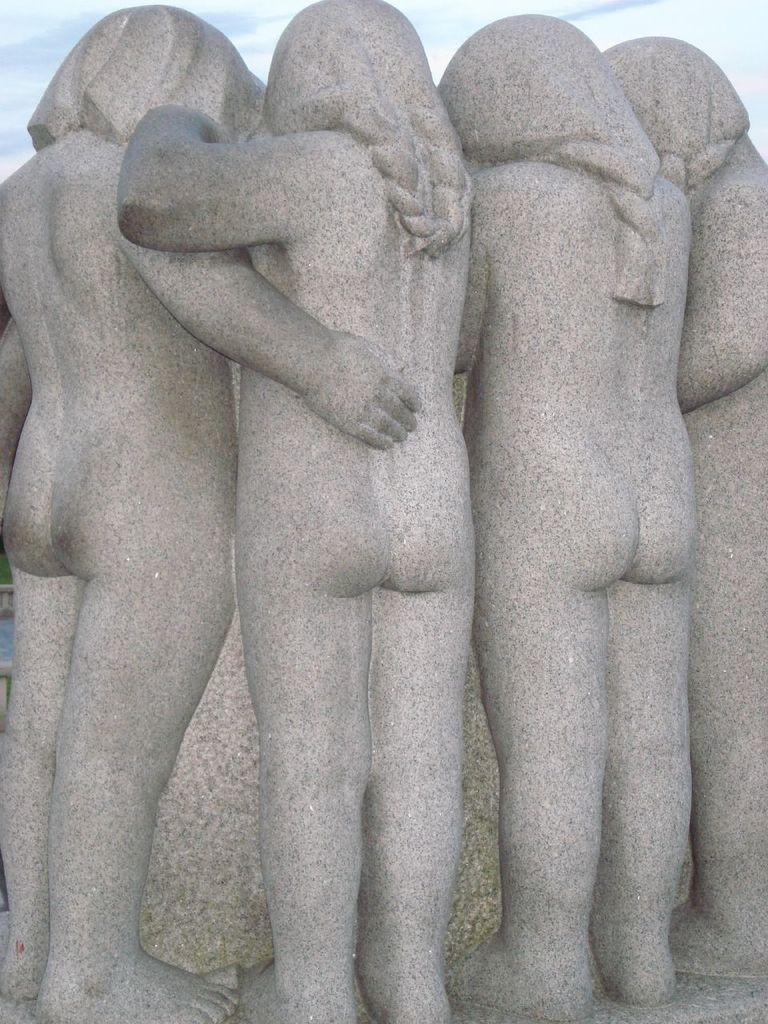Describe this image in one or two sentences. In this picture we can see few statues. 